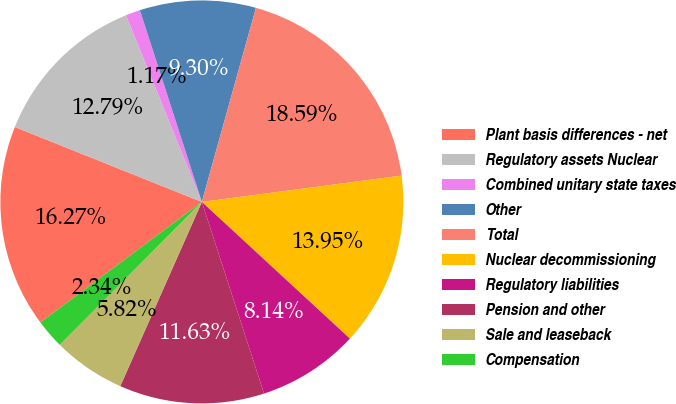Convert chart to OTSL. <chart><loc_0><loc_0><loc_500><loc_500><pie_chart><fcel>Plant basis differences - net<fcel>Regulatory assets Nuclear<fcel>Combined unitary state taxes<fcel>Other<fcel>Total<fcel>Nuclear decommissioning<fcel>Regulatory liabilities<fcel>Pension and other<fcel>Sale and leaseback<fcel>Compensation<nl><fcel>16.27%<fcel>12.79%<fcel>1.17%<fcel>9.3%<fcel>18.59%<fcel>13.95%<fcel>8.14%<fcel>11.63%<fcel>5.82%<fcel>2.34%<nl></chart> 